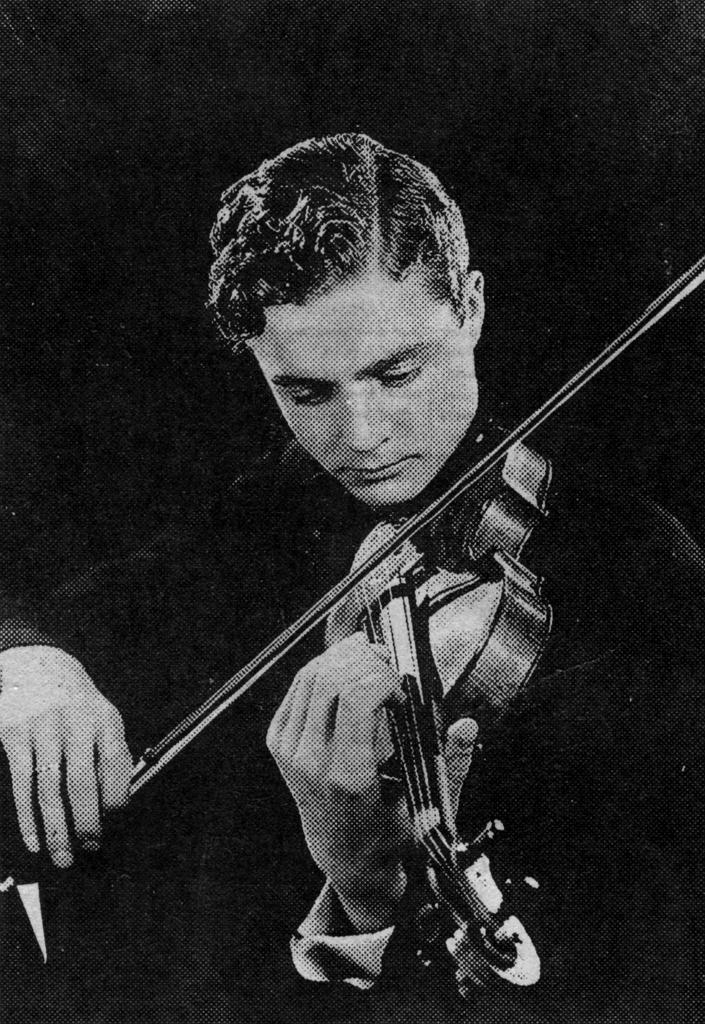Describe this image in one or two sentences. In this image I can see a man playing a musical instrument. 